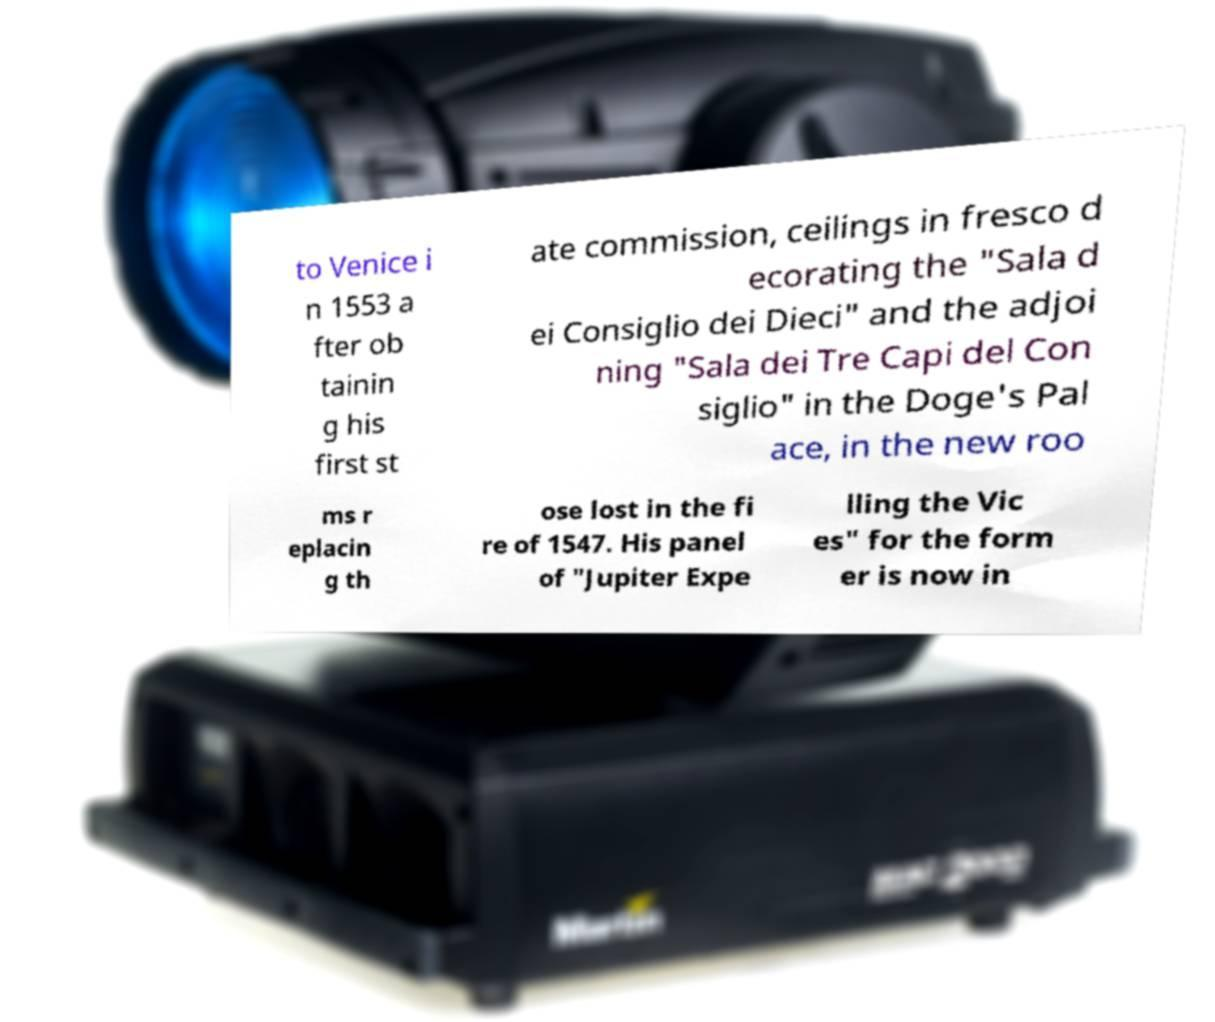What messages or text are displayed in this image? I need them in a readable, typed format. to Venice i n 1553 a fter ob tainin g his first st ate commission, ceilings in fresco d ecorating the "Sala d ei Consiglio dei Dieci" and the adjoi ning "Sala dei Tre Capi del Con siglio" in the Doge's Pal ace, in the new roo ms r eplacin g th ose lost in the fi re of 1547. His panel of "Jupiter Expe lling the Vic es" for the form er is now in 